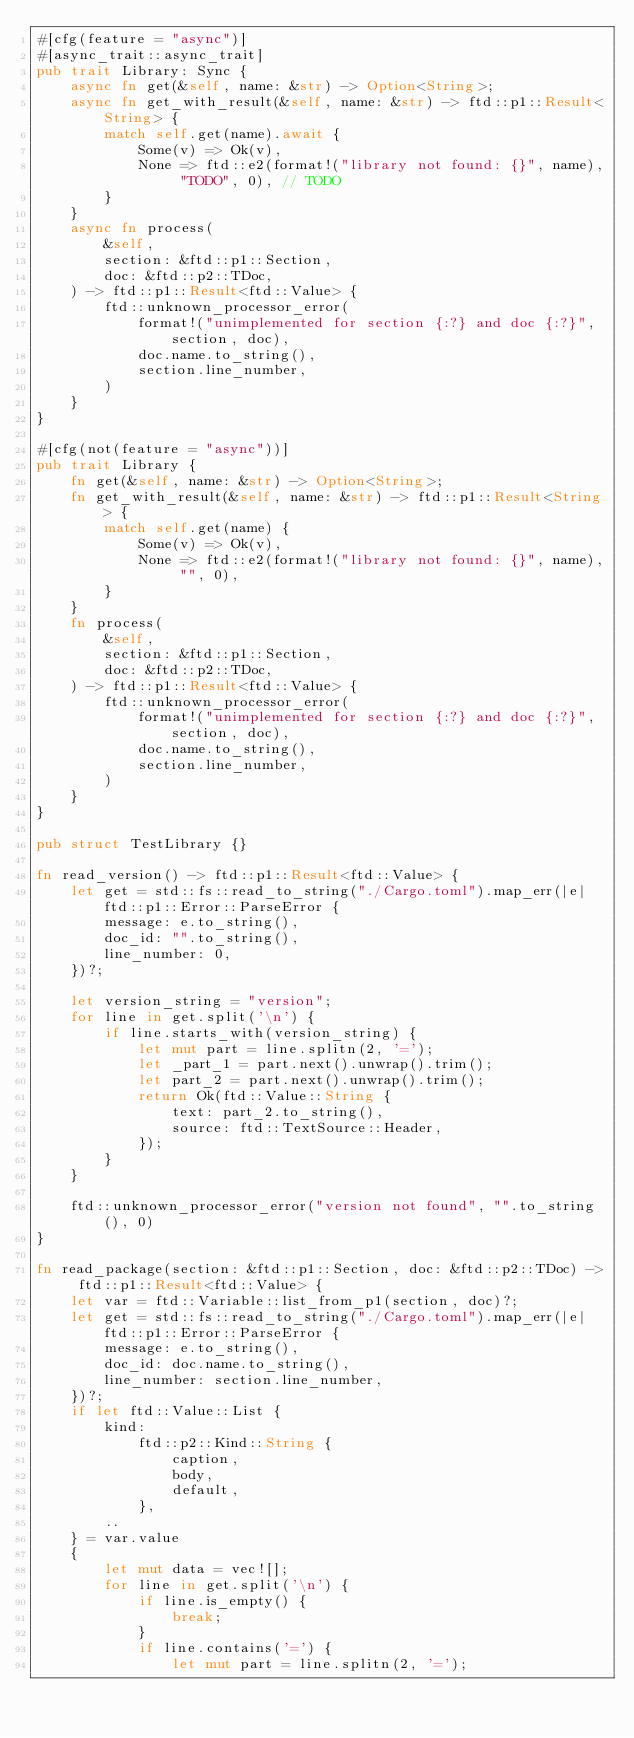Convert code to text. <code><loc_0><loc_0><loc_500><loc_500><_Rust_>#[cfg(feature = "async")]
#[async_trait::async_trait]
pub trait Library: Sync {
    async fn get(&self, name: &str) -> Option<String>;
    async fn get_with_result(&self, name: &str) -> ftd::p1::Result<String> {
        match self.get(name).await {
            Some(v) => Ok(v),
            None => ftd::e2(format!("library not found: {}", name), "TODO", 0), // TODO
        }
    }
    async fn process(
        &self,
        section: &ftd::p1::Section,
        doc: &ftd::p2::TDoc,
    ) -> ftd::p1::Result<ftd::Value> {
        ftd::unknown_processor_error(
            format!("unimplemented for section {:?} and doc {:?}", section, doc),
            doc.name.to_string(),
            section.line_number,
        )
    }
}

#[cfg(not(feature = "async"))]
pub trait Library {
    fn get(&self, name: &str) -> Option<String>;
    fn get_with_result(&self, name: &str) -> ftd::p1::Result<String> {
        match self.get(name) {
            Some(v) => Ok(v),
            None => ftd::e2(format!("library not found: {}", name), "", 0),
        }
    }
    fn process(
        &self,
        section: &ftd::p1::Section,
        doc: &ftd::p2::TDoc,
    ) -> ftd::p1::Result<ftd::Value> {
        ftd::unknown_processor_error(
            format!("unimplemented for section {:?} and doc {:?}", section, doc),
            doc.name.to_string(),
            section.line_number,
        )
    }
}

pub struct TestLibrary {}

fn read_version() -> ftd::p1::Result<ftd::Value> {
    let get = std::fs::read_to_string("./Cargo.toml").map_err(|e| ftd::p1::Error::ParseError {
        message: e.to_string(),
        doc_id: "".to_string(),
        line_number: 0,
    })?;

    let version_string = "version";
    for line in get.split('\n') {
        if line.starts_with(version_string) {
            let mut part = line.splitn(2, '=');
            let _part_1 = part.next().unwrap().trim();
            let part_2 = part.next().unwrap().trim();
            return Ok(ftd::Value::String {
                text: part_2.to_string(),
                source: ftd::TextSource::Header,
            });
        }
    }

    ftd::unknown_processor_error("version not found", "".to_string(), 0)
}

fn read_package(section: &ftd::p1::Section, doc: &ftd::p2::TDoc) -> ftd::p1::Result<ftd::Value> {
    let var = ftd::Variable::list_from_p1(section, doc)?;
    let get = std::fs::read_to_string("./Cargo.toml").map_err(|e| ftd::p1::Error::ParseError {
        message: e.to_string(),
        doc_id: doc.name.to_string(),
        line_number: section.line_number,
    })?;
    if let ftd::Value::List {
        kind:
            ftd::p2::Kind::String {
                caption,
                body,
                default,
            },
        ..
    } = var.value
    {
        let mut data = vec![];
        for line in get.split('\n') {
            if line.is_empty() {
                break;
            }
            if line.contains('=') {
                let mut part = line.splitn(2, '=');</code> 